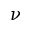Convert formula to latex. <formula><loc_0><loc_0><loc_500><loc_500>\nu</formula> 